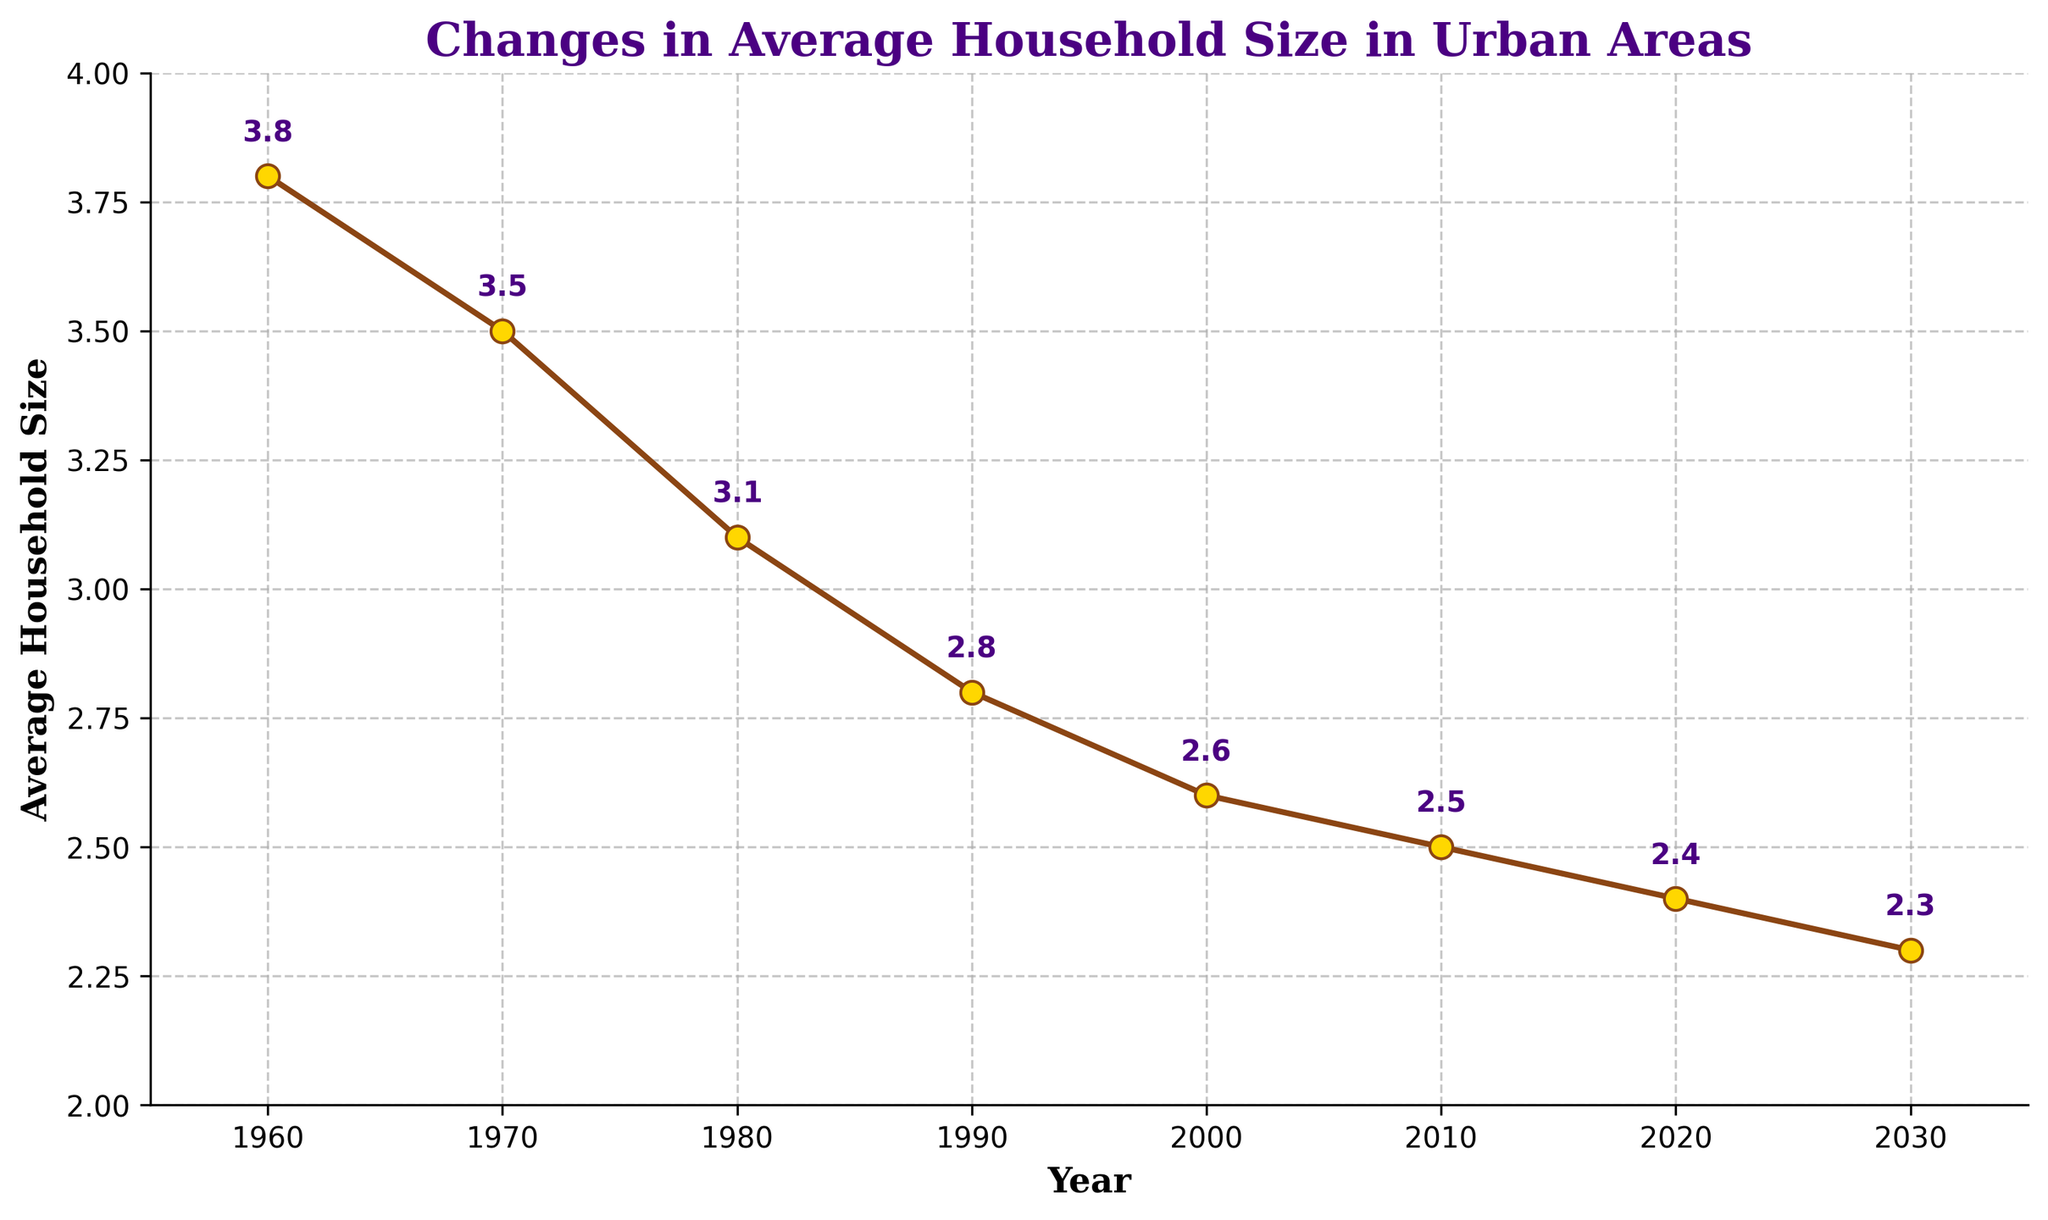What is the average household size in 1980? The figure clearly marks the average household sizes for each year. In 1980, the household size is annotated next to the point on the line corresponding to the year 1980.
Answer: 3.1 Which year had the smallest average household size? By observing the annotated data points in the figure, the smallest average household size occurs in 2030. The value in 2030 is annotated as 2.3, which is the lowest value on the chart.
Answer: 2030 How much did the average household size decrease from 1960 to 2000? First, find the household sizes for 1960 and 2000 from the chart: 3.8 in 1960 and 2.6 in 2000. Subtract the value in 2000 from the value in 1960 to find the decrease: 3.8 - 2.6 = 1.2.
Answer: 1.2 In which decade did the average household size decrease the most? By comparing the annotated values for each decade, calculate the difference: 1960-1970 (3.8 to 3.5, decrease of 0.3), 1970-1980 (3.5 to 3.1, decrease of 0.4), 1980-1990 (3.1 to 2.8, decrease of 0.3), 1990-2000 (2.8 to 2.6, decrease of 0.2), 2000-2010 (2.6 to 2.5, decrease of 0.1). The largest decrease is from 1970 to 1980, which is 0.4.
Answer: 1970-1980 What is the difference in the average household size between 1990 and 2020? Locate the values for 1990 and 2020 in the chart: 2.8 in 1990 and 2.4 in 2020. Subtract the value in 2020 from the value in 1990: 2.8 - 2.4 = 0.4.
Answer: 0.4 Which year had an average household size closest to 3? By looking at the annotated values in the figure, 1980 has an average household size of 3.1, which is closest to 3 compared to other years.
Answer: 1980 Is there a year when the average household size remained the same as the previous decade? Compare each pair of decades to see if the values are equal. The chart shows that the average household size changes gradually and does not remain the same between any decades.
Answer: No Between which years did the average household size drop by 0.1 for the first time? By tracing the annotated values in the chart, the first drop of 0.1 occurs between 2000 (2.6) and 2010 (2.5).
Answer: 2000 and 2010 